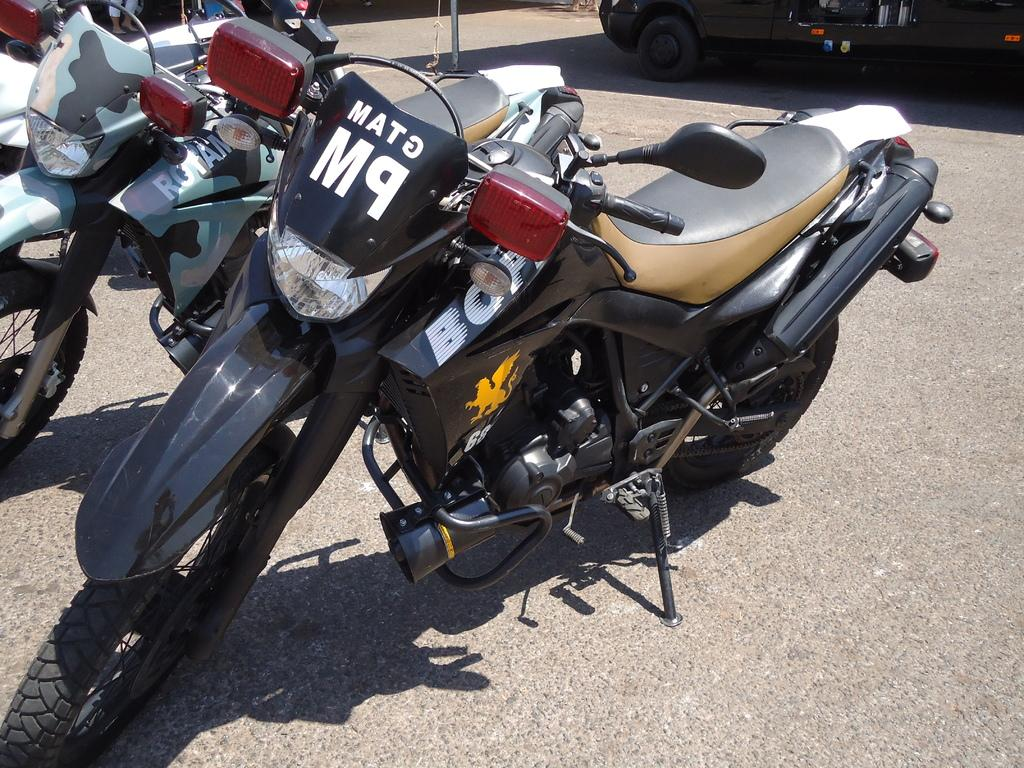What type of vehicles are present in the image? There are bikes and a car in the image. Where are the bikes and car located? The bikes and car are on a road. What type of dinner is being served in the image? There is no dinner present in the image; it features bikes and a car on a road. What book is the car reading in the image? There is no book present in the image, as cars do not read books. 